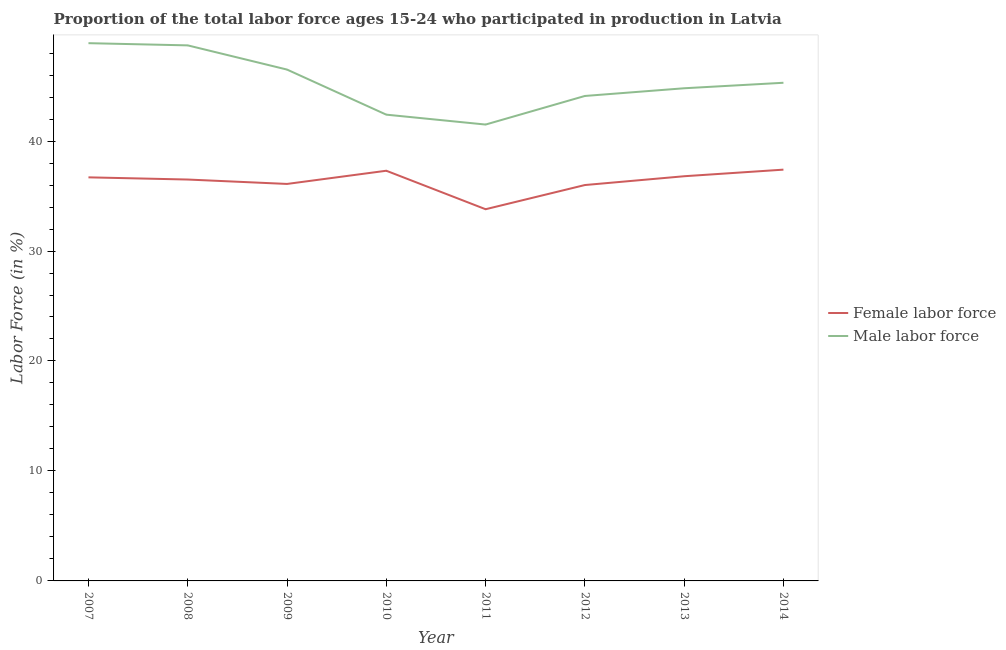How many different coloured lines are there?
Your response must be concise. 2. Is the number of lines equal to the number of legend labels?
Your response must be concise. Yes. What is the percentage of male labour force in 2008?
Make the answer very short. 48.7. Across all years, what is the maximum percentage of male labour force?
Offer a terse response. 48.9. Across all years, what is the minimum percentage of female labor force?
Provide a succinct answer. 33.8. In which year was the percentage of female labor force maximum?
Provide a succinct answer. 2014. In which year was the percentage of male labour force minimum?
Make the answer very short. 2011. What is the total percentage of male labour force in the graph?
Provide a short and direct response. 362.2. What is the difference between the percentage of male labour force in 2010 and that in 2013?
Your response must be concise. -2.4. What is the difference between the percentage of female labor force in 2013 and the percentage of male labour force in 2012?
Ensure brevity in your answer.  -7.3. What is the average percentage of female labor force per year?
Give a very brief answer. 36.32. In the year 2007, what is the difference between the percentage of male labour force and percentage of female labor force?
Ensure brevity in your answer.  12.2. What is the ratio of the percentage of male labour force in 2010 to that in 2014?
Make the answer very short. 0.94. Is the percentage of male labour force in 2007 less than that in 2011?
Provide a short and direct response. No. What is the difference between the highest and the second highest percentage of female labor force?
Offer a very short reply. 0.1. What is the difference between the highest and the lowest percentage of female labor force?
Your answer should be compact. 3.6. In how many years, is the percentage of male labour force greater than the average percentage of male labour force taken over all years?
Your response must be concise. 4. How many lines are there?
Ensure brevity in your answer.  2. Where does the legend appear in the graph?
Your answer should be very brief. Center right. How are the legend labels stacked?
Ensure brevity in your answer.  Vertical. What is the title of the graph?
Offer a very short reply. Proportion of the total labor force ages 15-24 who participated in production in Latvia. Does "RDB nonconcessional" appear as one of the legend labels in the graph?
Make the answer very short. No. What is the label or title of the X-axis?
Your answer should be compact. Year. What is the Labor Force (in %) in Female labor force in 2007?
Offer a very short reply. 36.7. What is the Labor Force (in %) in Male labor force in 2007?
Make the answer very short. 48.9. What is the Labor Force (in %) of Female labor force in 2008?
Make the answer very short. 36.5. What is the Labor Force (in %) of Male labor force in 2008?
Offer a terse response. 48.7. What is the Labor Force (in %) of Female labor force in 2009?
Make the answer very short. 36.1. What is the Labor Force (in %) of Male labor force in 2009?
Your answer should be compact. 46.5. What is the Labor Force (in %) in Female labor force in 2010?
Offer a very short reply. 37.3. What is the Labor Force (in %) in Male labor force in 2010?
Make the answer very short. 42.4. What is the Labor Force (in %) of Female labor force in 2011?
Your answer should be very brief. 33.8. What is the Labor Force (in %) in Male labor force in 2011?
Ensure brevity in your answer.  41.5. What is the Labor Force (in %) in Female labor force in 2012?
Give a very brief answer. 36. What is the Labor Force (in %) in Male labor force in 2012?
Your answer should be compact. 44.1. What is the Labor Force (in %) of Female labor force in 2013?
Keep it short and to the point. 36.8. What is the Labor Force (in %) in Male labor force in 2013?
Your answer should be very brief. 44.8. What is the Labor Force (in %) in Female labor force in 2014?
Your answer should be compact. 37.4. What is the Labor Force (in %) in Male labor force in 2014?
Make the answer very short. 45.3. Across all years, what is the maximum Labor Force (in %) of Female labor force?
Keep it short and to the point. 37.4. Across all years, what is the maximum Labor Force (in %) of Male labor force?
Offer a very short reply. 48.9. Across all years, what is the minimum Labor Force (in %) in Female labor force?
Offer a very short reply. 33.8. Across all years, what is the minimum Labor Force (in %) in Male labor force?
Offer a terse response. 41.5. What is the total Labor Force (in %) in Female labor force in the graph?
Offer a terse response. 290.6. What is the total Labor Force (in %) of Male labor force in the graph?
Your answer should be compact. 362.2. What is the difference between the Labor Force (in %) of Female labor force in 2007 and that in 2008?
Provide a short and direct response. 0.2. What is the difference between the Labor Force (in %) of Female labor force in 2007 and that in 2010?
Offer a terse response. -0.6. What is the difference between the Labor Force (in %) of Male labor force in 2007 and that in 2011?
Offer a very short reply. 7.4. What is the difference between the Labor Force (in %) in Female labor force in 2007 and that in 2012?
Give a very brief answer. 0.7. What is the difference between the Labor Force (in %) of Male labor force in 2007 and that in 2012?
Give a very brief answer. 4.8. What is the difference between the Labor Force (in %) of Female labor force in 2007 and that in 2013?
Your response must be concise. -0.1. What is the difference between the Labor Force (in %) in Male labor force in 2007 and that in 2013?
Your answer should be compact. 4.1. What is the difference between the Labor Force (in %) in Female labor force in 2007 and that in 2014?
Provide a succinct answer. -0.7. What is the difference between the Labor Force (in %) of Male labor force in 2007 and that in 2014?
Provide a succinct answer. 3.6. What is the difference between the Labor Force (in %) of Female labor force in 2008 and that in 2009?
Offer a terse response. 0.4. What is the difference between the Labor Force (in %) in Male labor force in 2008 and that in 2009?
Give a very brief answer. 2.2. What is the difference between the Labor Force (in %) of Male labor force in 2008 and that in 2010?
Provide a succinct answer. 6.3. What is the difference between the Labor Force (in %) in Female labor force in 2008 and that in 2012?
Ensure brevity in your answer.  0.5. What is the difference between the Labor Force (in %) of Female labor force in 2008 and that in 2013?
Make the answer very short. -0.3. What is the difference between the Labor Force (in %) in Male labor force in 2008 and that in 2013?
Offer a very short reply. 3.9. What is the difference between the Labor Force (in %) of Female labor force in 2008 and that in 2014?
Keep it short and to the point. -0.9. What is the difference between the Labor Force (in %) in Female labor force in 2009 and that in 2010?
Your response must be concise. -1.2. What is the difference between the Labor Force (in %) of Male labor force in 2009 and that in 2010?
Offer a terse response. 4.1. What is the difference between the Labor Force (in %) in Female labor force in 2009 and that in 2011?
Your answer should be very brief. 2.3. What is the difference between the Labor Force (in %) of Female labor force in 2009 and that in 2012?
Your answer should be very brief. 0.1. What is the difference between the Labor Force (in %) of Male labor force in 2009 and that in 2012?
Keep it short and to the point. 2.4. What is the difference between the Labor Force (in %) of Male labor force in 2009 and that in 2013?
Provide a succinct answer. 1.7. What is the difference between the Labor Force (in %) of Female labor force in 2009 and that in 2014?
Offer a terse response. -1.3. What is the difference between the Labor Force (in %) in Male labor force in 2009 and that in 2014?
Provide a succinct answer. 1.2. What is the difference between the Labor Force (in %) in Female labor force in 2010 and that in 2012?
Your answer should be compact. 1.3. What is the difference between the Labor Force (in %) in Male labor force in 2010 and that in 2012?
Offer a very short reply. -1.7. What is the difference between the Labor Force (in %) in Female labor force in 2010 and that in 2013?
Make the answer very short. 0.5. What is the difference between the Labor Force (in %) in Male labor force in 2010 and that in 2013?
Offer a terse response. -2.4. What is the difference between the Labor Force (in %) of Female labor force in 2011 and that in 2012?
Your response must be concise. -2.2. What is the difference between the Labor Force (in %) of Male labor force in 2011 and that in 2012?
Offer a very short reply. -2.6. What is the difference between the Labor Force (in %) in Female labor force in 2011 and that in 2014?
Your response must be concise. -3.6. What is the difference between the Labor Force (in %) of Female labor force in 2012 and that in 2014?
Offer a very short reply. -1.4. What is the difference between the Labor Force (in %) in Female labor force in 2007 and the Labor Force (in %) in Male labor force in 2008?
Offer a terse response. -12. What is the difference between the Labor Force (in %) in Female labor force in 2007 and the Labor Force (in %) in Male labor force in 2009?
Keep it short and to the point. -9.8. What is the difference between the Labor Force (in %) in Female labor force in 2007 and the Labor Force (in %) in Male labor force in 2013?
Offer a terse response. -8.1. What is the difference between the Labor Force (in %) of Female labor force in 2008 and the Labor Force (in %) of Male labor force in 2009?
Your answer should be very brief. -10. What is the difference between the Labor Force (in %) in Female labor force in 2008 and the Labor Force (in %) in Male labor force in 2010?
Your answer should be very brief. -5.9. What is the difference between the Labor Force (in %) in Female labor force in 2008 and the Labor Force (in %) in Male labor force in 2011?
Your response must be concise. -5. What is the difference between the Labor Force (in %) in Female labor force in 2008 and the Labor Force (in %) in Male labor force in 2013?
Provide a succinct answer. -8.3. What is the difference between the Labor Force (in %) of Female labor force in 2009 and the Labor Force (in %) of Male labor force in 2012?
Provide a short and direct response. -8. What is the difference between the Labor Force (in %) in Female labor force in 2009 and the Labor Force (in %) in Male labor force in 2013?
Offer a terse response. -8.7. What is the difference between the Labor Force (in %) in Female labor force in 2009 and the Labor Force (in %) in Male labor force in 2014?
Ensure brevity in your answer.  -9.2. What is the difference between the Labor Force (in %) in Female labor force in 2010 and the Labor Force (in %) in Male labor force in 2011?
Offer a terse response. -4.2. What is the difference between the Labor Force (in %) in Female labor force in 2010 and the Labor Force (in %) in Male labor force in 2012?
Your answer should be very brief. -6.8. What is the difference between the Labor Force (in %) in Female labor force in 2010 and the Labor Force (in %) in Male labor force in 2013?
Your response must be concise. -7.5. What is the difference between the Labor Force (in %) in Female labor force in 2011 and the Labor Force (in %) in Male labor force in 2012?
Ensure brevity in your answer.  -10.3. What is the difference between the Labor Force (in %) of Female labor force in 2011 and the Labor Force (in %) of Male labor force in 2013?
Provide a succinct answer. -11. What is the difference between the Labor Force (in %) of Female labor force in 2012 and the Labor Force (in %) of Male labor force in 2013?
Your answer should be compact. -8.8. What is the difference between the Labor Force (in %) in Female labor force in 2013 and the Labor Force (in %) in Male labor force in 2014?
Offer a very short reply. -8.5. What is the average Labor Force (in %) in Female labor force per year?
Your response must be concise. 36.33. What is the average Labor Force (in %) of Male labor force per year?
Give a very brief answer. 45.27. In the year 2009, what is the difference between the Labor Force (in %) of Female labor force and Labor Force (in %) of Male labor force?
Your answer should be compact. -10.4. In the year 2010, what is the difference between the Labor Force (in %) of Female labor force and Labor Force (in %) of Male labor force?
Your answer should be compact. -5.1. In the year 2013, what is the difference between the Labor Force (in %) of Female labor force and Labor Force (in %) of Male labor force?
Provide a short and direct response. -8. In the year 2014, what is the difference between the Labor Force (in %) in Female labor force and Labor Force (in %) in Male labor force?
Ensure brevity in your answer.  -7.9. What is the ratio of the Labor Force (in %) of Female labor force in 2007 to that in 2008?
Keep it short and to the point. 1.01. What is the ratio of the Labor Force (in %) of Female labor force in 2007 to that in 2009?
Your answer should be very brief. 1.02. What is the ratio of the Labor Force (in %) of Male labor force in 2007 to that in 2009?
Your answer should be compact. 1.05. What is the ratio of the Labor Force (in %) in Female labor force in 2007 to that in 2010?
Provide a succinct answer. 0.98. What is the ratio of the Labor Force (in %) of Male labor force in 2007 to that in 2010?
Offer a terse response. 1.15. What is the ratio of the Labor Force (in %) of Female labor force in 2007 to that in 2011?
Provide a succinct answer. 1.09. What is the ratio of the Labor Force (in %) in Male labor force in 2007 to that in 2011?
Provide a short and direct response. 1.18. What is the ratio of the Labor Force (in %) in Female labor force in 2007 to that in 2012?
Offer a terse response. 1.02. What is the ratio of the Labor Force (in %) in Male labor force in 2007 to that in 2012?
Your response must be concise. 1.11. What is the ratio of the Labor Force (in %) in Male labor force in 2007 to that in 2013?
Your response must be concise. 1.09. What is the ratio of the Labor Force (in %) in Female labor force in 2007 to that in 2014?
Your answer should be compact. 0.98. What is the ratio of the Labor Force (in %) of Male labor force in 2007 to that in 2014?
Your answer should be compact. 1.08. What is the ratio of the Labor Force (in %) in Female labor force in 2008 to that in 2009?
Provide a succinct answer. 1.01. What is the ratio of the Labor Force (in %) in Male labor force in 2008 to that in 2009?
Your answer should be compact. 1.05. What is the ratio of the Labor Force (in %) of Female labor force in 2008 to that in 2010?
Make the answer very short. 0.98. What is the ratio of the Labor Force (in %) of Male labor force in 2008 to that in 2010?
Ensure brevity in your answer.  1.15. What is the ratio of the Labor Force (in %) in Female labor force in 2008 to that in 2011?
Make the answer very short. 1.08. What is the ratio of the Labor Force (in %) of Male labor force in 2008 to that in 2011?
Provide a succinct answer. 1.17. What is the ratio of the Labor Force (in %) in Female labor force in 2008 to that in 2012?
Give a very brief answer. 1.01. What is the ratio of the Labor Force (in %) of Male labor force in 2008 to that in 2012?
Your response must be concise. 1.1. What is the ratio of the Labor Force (in %) of Male labor force in 2008 to that in 2013?
Ensure brevity in your answer.  1.09. What is the ratio of the Labor Force (in %) in Female labor force in 2008 to that in 2014?
Offer a very short reply. 0.98. What is the ratio of the Labor Force (in %) in Male labor force in 2008 to that in 2014?
Give a very brief answer. 1.08. What is the ratio of the Labor Force (in %) in Female labor force in 2009 to that in 2010?
Give a very brief answer. 0.97. What is the ratio of the Labor Force (in %) of Male labor force in 2009 to that in 2010?
Provide a short and direct response. 1.1. What is the ratio of the Labor Force (in %) of Female labor force in 2009 to that in 2011?
Offer a terse response. 1.07. What is the ratio of the Labor Force (in %) in Male labor force in 2009 to that in 2011?
Give a very brief answer. 1.12. What is the ratio of the Labor Force (in %) of Female labor force in 2009 to that in 2012?
Ensure brevity in your answer.  1. What is the ratio of the Labor Force (in %) of Male labor force in 2009 to that in 2012?
Your answer should be compact. 1.05. What is the ratio of the Labor Force (in %) in Male labor force in 2009 to that in 2013?
Offer a terse response. 1.04. What is the ratio of the Labor Force (in %) in Female labor force in 2009 to that in 2014?
Your response must be concise. 0.97. What is the ratio of the Labor Force (in %) of Male labor force in 2009 to that in 2014?
Your response must be concise. 1.03. What is the ratio of the Labor Force (in %) of Female labor force in 2010 to that in 2011?
Your answer should be compact. 1.1. What is the ratio of the Labor Force (in %) of Male labor force in 2010 to that in 2011?
Offer a very short reply. 1.02. What is the ratio of the Labor Force (in %) in Female labor force in 2010 to that in 2012?
Offer a very short reply. 1.04. What is the ratio of the Labor Force (in %) in Male labor force in 2010 to that in 2012?
Your answer should be compact. 0.96. What is the ratio of the Labor Force (in %) of Female labor force in 2010 to that in 2013?
Provide a short and direct response. 1.01. What is the ratio of the Labor Force (in %) of Male labor force in 2010 to that in 2013?
Your response must be concise. 0.95. What is the ratio of the Labor Force (in %) of Female labor force in 2010 to that in 2014?
Your answer should be compact. 1. What is the ratio of the Labor Force (in %) in Male labor force in 2010 to that in 2014?
Provide a succinct answer. 0.94. What is the ratio of the Labor Force (in %) in Female labor force in 2011 to that in 2012?
Offer a very short reply. 0.94. What is the ratio of the Labor Force (in %) of Male labor force in 2011 to that in 2012?
Ensure brevity in your answer.  0.94. What is the ratio of the Labor Force (in %) in Female labor force in 2011 to that in 2013?
Provide a succinct answer. 0.92. What is the ratio of the Labor Force (in %) in Male labor force in 2011 to that in 2013?
Keep it short and to the point. 0.93. What is the ratio of the Labor Force (in %) of Female labor force in 2011 to that in 2014?
Provide a succinct answer. 0.9. What is the ratio of the Labor Force (in %) of Male labor force in 2011 to that in 2014?
Provide a short and direct response. 0.92. What is the ratio of the Labor Force (in %) in Female labor force in 2012 to that in 2013?
Your answer should be very brief. 0.98. What is the ratio of the Labor Force (in %) of Male labor force in 2012 to that in 2013?
Provide a succinct answer. 0.98. What is the ratio of the Labor Force (in %) in Female labor force in 2012 to that in 2014?
Provide a short and direct response. 0.96. What is the ratio of the Labor Force (in %) in Male labor force in 2012 to that in 2014?
Ensure brevity in your answer.  0.97. What is the ratio of the Labor Force (in %) in Female labor force in 2013 to that in 2014?
Keep it short and to the point. 0.98. What is the difference between the highest and the second highest Labor Force (in %) in Female labor force?
Ensure brevity in your answer.  0.1. What is the difference between the highest and the second highest Labor Force (in %) in Male labor force?
Ensure brevity in your answer.  0.2. What is the difference between the highest and the lowest Labor Force (in %) of Female labor force?
Your answer should be compact. 3.6. 